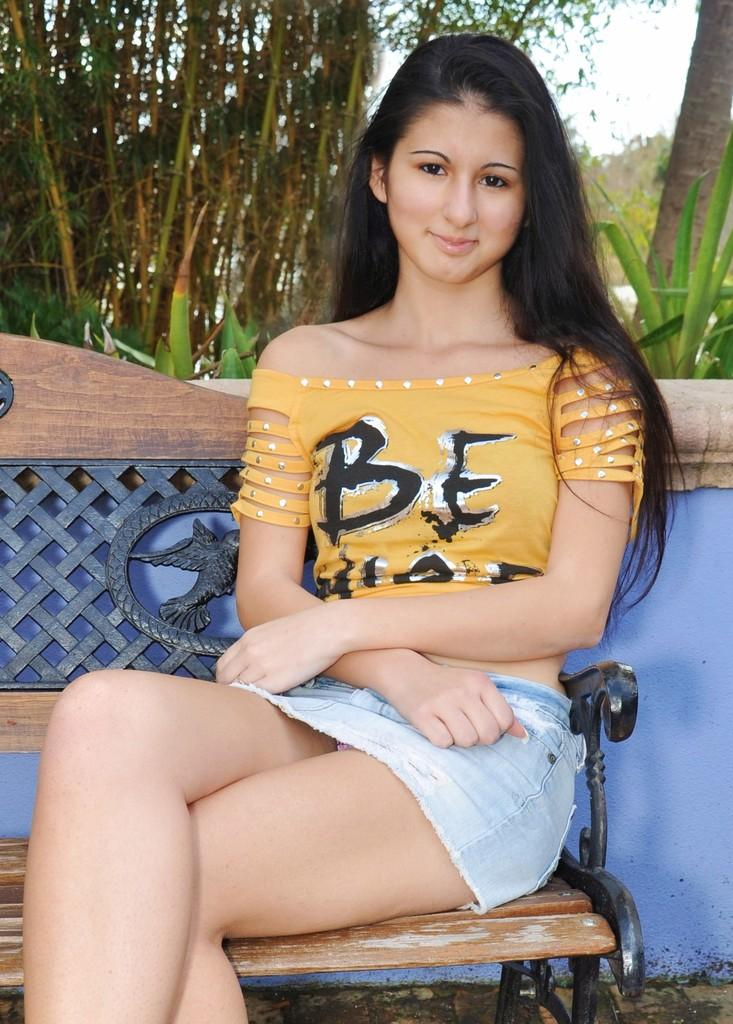Who is the main subject in the image? There is a girl in the image. What is the girl doing in the image? The girl is sitting on a bench. What can be seen in the background of the image? There are trees and the sky visible in the background of the image. What type of ornament is the girl wearing in the image? There is no mention of an ornament in the image, so it cannot be determined if the girl is wearing one. 